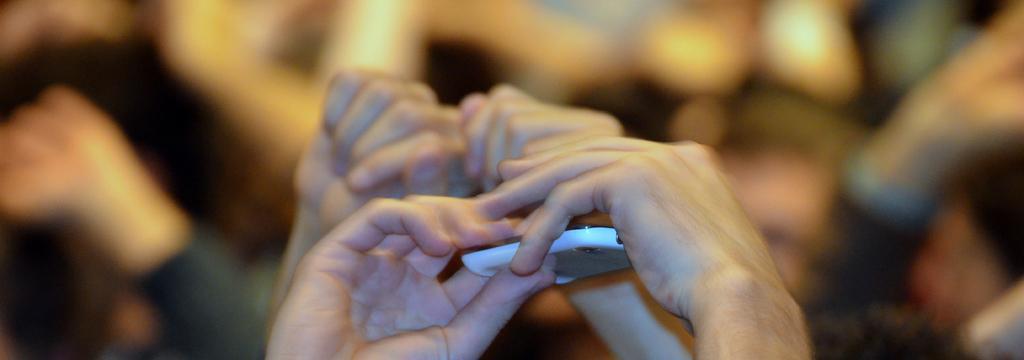Could you give a brief overview of what you see in this image? At the bottom of the picture, we see the hands of the person holding white color thing which looks like a mobile phone. Behind that, we see the hands of a person. In the background, it is blurred. 